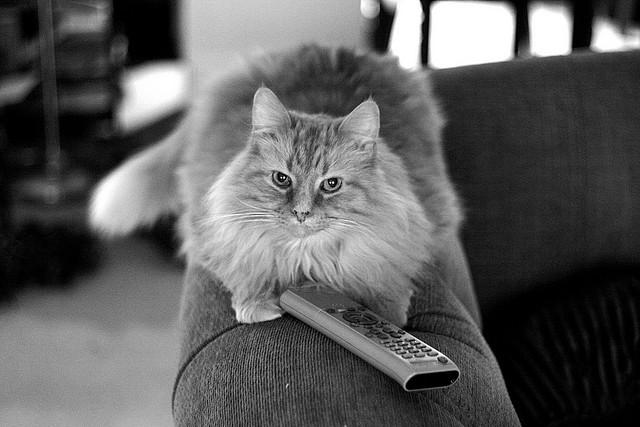How is the cat on the couch illuminated? Please explain your reasoning. sunlight. It appears that there are windows very near the cat so it's easy to assume that it is indeed sunlight that is providing illumination. 